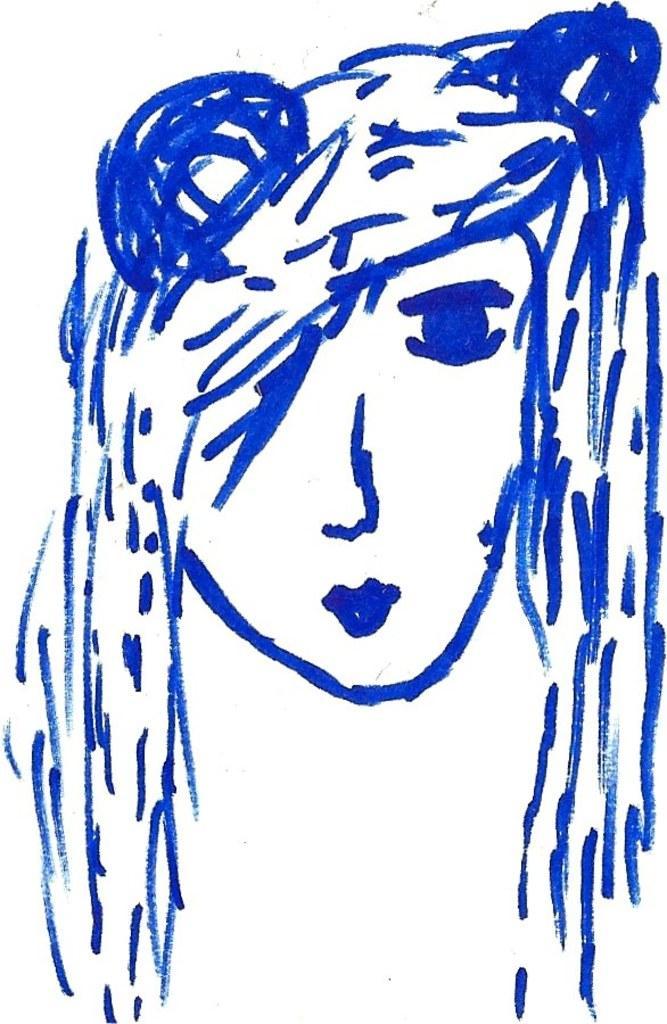How would you summarize this image in a sentence or two? This image consists of a drawing of a person's head. It is in blue color. 